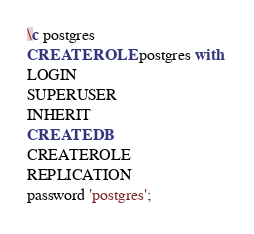Convert code to text. <code><loc_0><loc_0><loc_500><loc_500><_SQL_>\c postgres
CREATE ROLE postgres with 
LOGIN
SUPERUSER
INHERIT
CREATEDB
CREATEROLE
REPLICATION
password 'postgres';</code> 